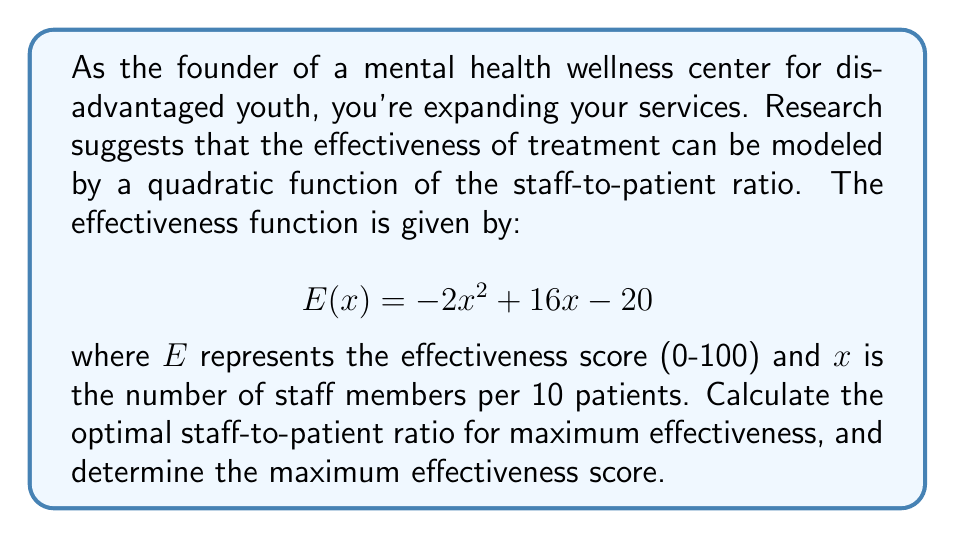Help me with this question. To solve this problem, we need to follow these steps:

1) The effectiveness function is a quadratic equation in the form $ax^2 + bx + c$, where:
   $a = -2$, $b = 16$, and $c = -20$

2) For a quadratic function, the maximum or minimum occurs at the vertex. Since $a$ is negative, this parabola opens downward, so the vertex will be the maximum point.

3) To find the x-coordinate of the vertex, we use the formula: $x = -\frac{b}{2a}$

   $x = -\frac{16}{2(-2)} = -\frac{16}{-4} = 4$

4) This means the optimal ratio is 4 staff members per 10 patients, or 2:5.

5) To find the maximum effectiveness score, we plug $x = 4$ into the original function:

   $$ E(4) = -2(4)^2 + 16(4) - 20 $$
   $$ = -2(16) + 64 - 20 $$
   $$ = -32 + 64 - 20 $$
   $$ = 12 $$

Therefore, the maximum effectiveness score is 12.
Answer: The optimal staff-to-patient ratio is 2:5 (4 staff per 10 patients), and the maximum effectiveness score is 12. 